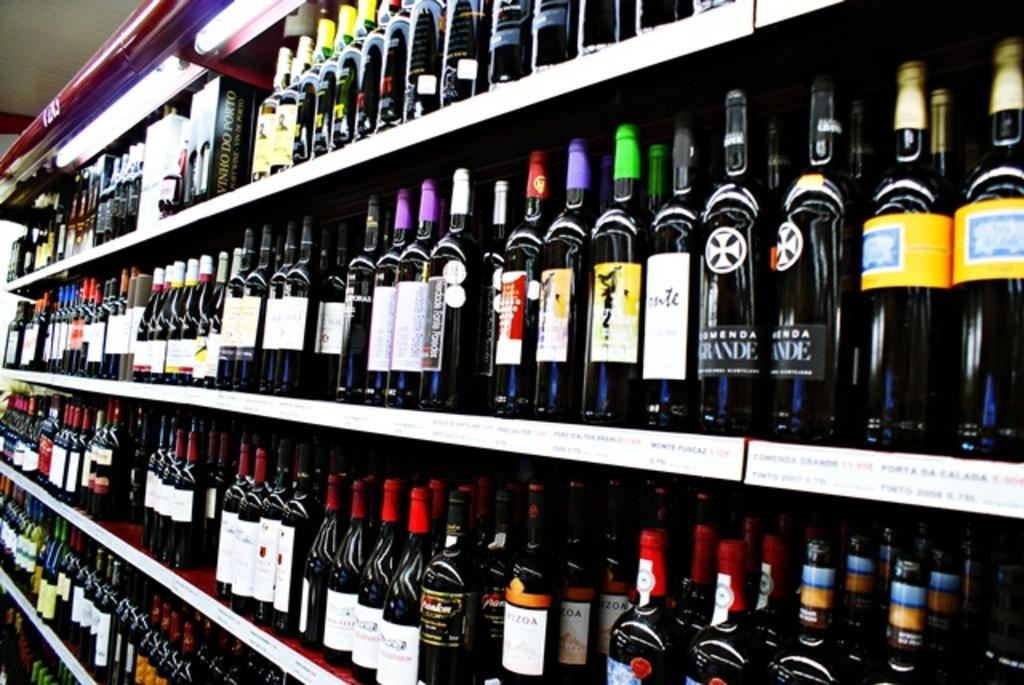<image>
Create a compact narrative representing the image presented. A rack of wines in a store, the words Vinio Do Porto are visible on a sign. 